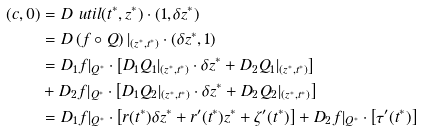<formula> <loc_0><loc_0><loc_500><loc_500>( c , 0 ) & = D \ u t i l ( t ^ { * } , z ^ { * } ) \cdot ( 1 , \delta z ^ { * } ) \\ & = D \left ( f \circ Q \right ) | _ { ( z ^ { * } , t ^ { * } ) } \cdot ( \delta z ^ { * } , 1 ) \\ & = D _ { 1 } f | _ { Q ^ { * } } \cdot \left [ D _ { 1 } Q _ { 1 } | _ { ( z ^ { * } , t ^ { * } ) } \cdot \delta z ^ { * } + D _ { 2 } Q _ { 1 } | _ { ( z ^ { * } , t ^ { * } ) } \right ] \\ & + D _ { 2 } f | _ { Q ^ { * } } \cdot \left [ D _ { 1 } Q _ { 2 } | _ { ( z ^ { * } , t ^ { * } ) } \cdot \delta z ^ { * } + D _ { 2 } Q _ { 2 } | _ { ( z ^ { * } , t ^ { * } ) } \right ] \\ & = D _ { 1 } f | _ { Q ^ { * } } \cdot \left [ r ( t ^ { * } ) \delta z ^ { * } + r ^ { \prime } ( t ^ { * } ) z ^ { * } + \zeta ^ { \prime } ( t ^ { * } ) \right ] + D _ { 2 } f | _ { Q ^ { * } } \cdot \left [ \tau ^ { \prime } ( t ^ { * } ) \right ]</formula> 